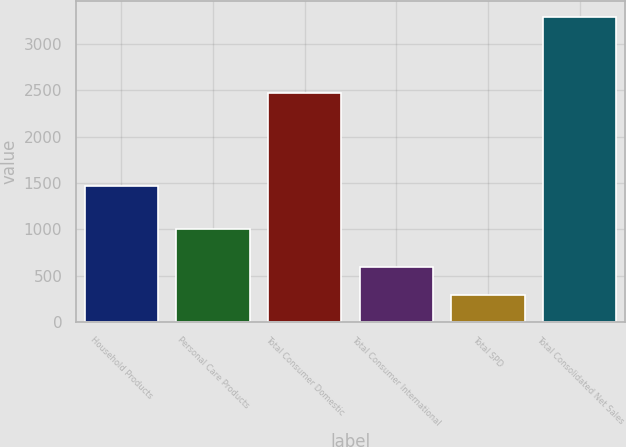Convert chart to OTSL. <chart><loc_0><loc_0><loc_500><loc_500><bar_chart><fcel>Household Products<fcel>Personal Care Products<fcel>Total Consumer Domestic<fcel>Total Consumer International<fcel>Total SPD<fcel>Total Consolidated Net Sales<nl><fcel>1466.2<fcel>1005.4<fcel>2471.6<fcel>591.48<fcel>290.8<fcel>3297.6<nl></chart> 